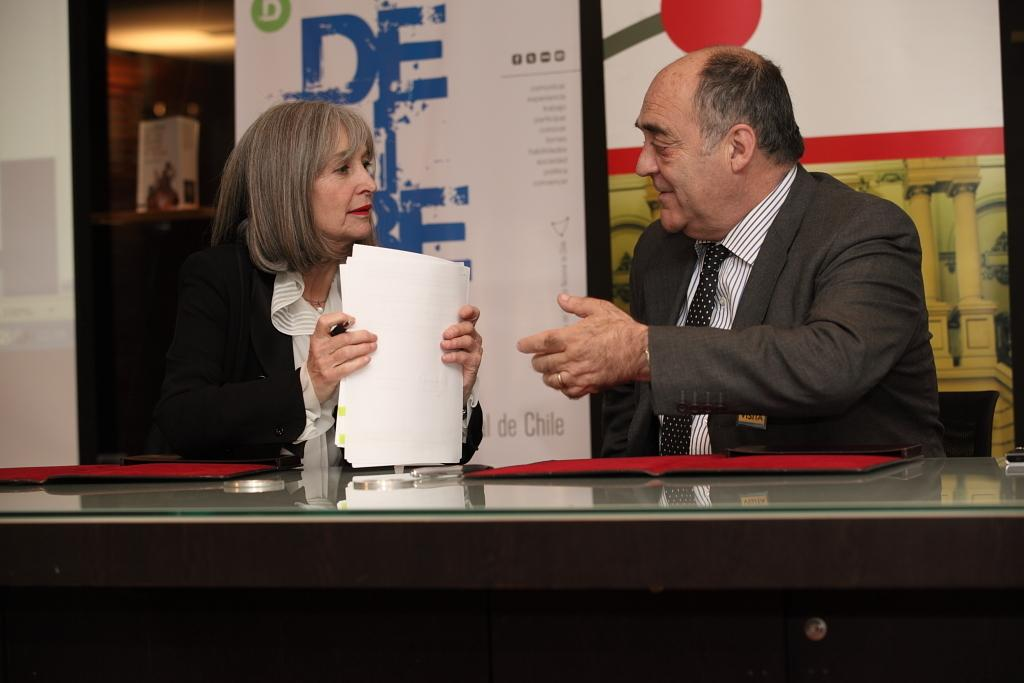What are the people in the image doing? The people in the image are sitting on chairs. What is the woman holding in her hand? The woman is holding papers in her hand. What can be seen on the table in the image? There are files on the table. What is visible in the background of the image? There are banners visible in the background. What type of carriage is being used to transport the people in the image? There is no carriage present in the image; the people are sitting on chairs. How many feet are visible in the image? The number of feet visible in the image cannot be determined from the provided facts. 